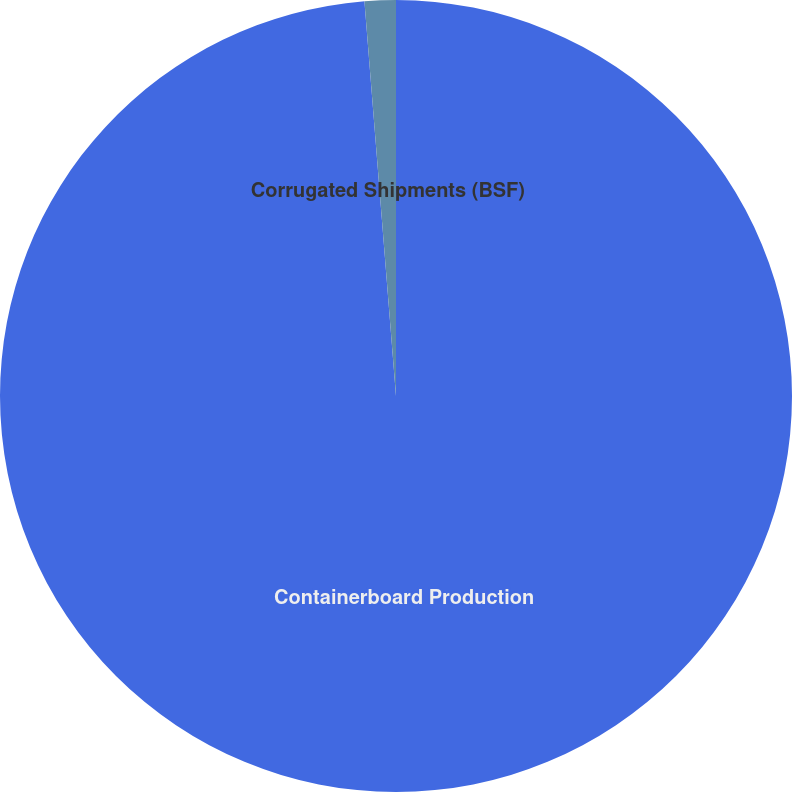Convert chart to OTSL. <chart><loc_0><loc_0><loc_500><loc_500><pie_chart><fcel>Containerboard Production<fcel>Corrugated Shipments (BSF)<nl><fcel>98.73%<fcel>1.27%<nl></chart> 